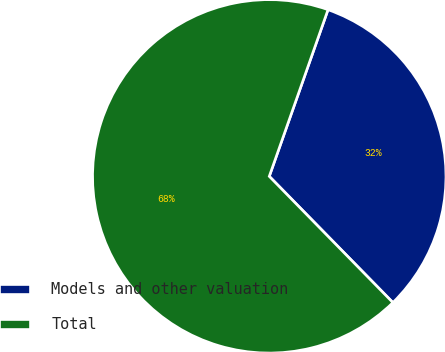<chart> <loc_0><loc_0><loc_500><loc_500><pie_chart><fcel>Models and other valuation<fcel>Total<nl><fcel>32.27%<fcel>67.73%<nl></chart> 